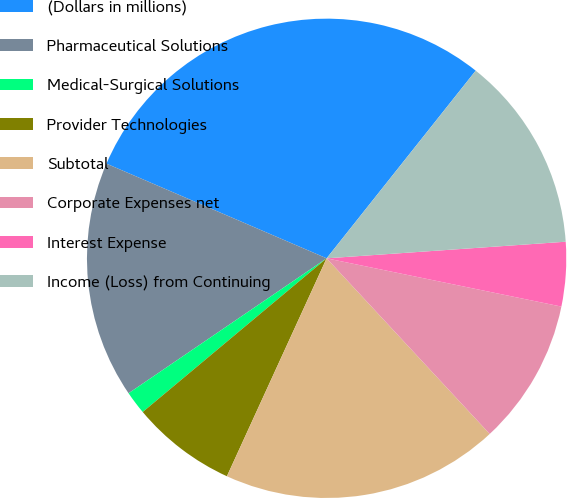Convert chart to OTSL. <chart><loc_0><loc_0><loc_500><loc_500><pie_chart><fcel>(Dollars in millions)<fcel>Pharmaceutical Solutions<fcel>Medical-Surgical Solutions<fcel>Provider Technologies<fcel>Subtotal<fcel>Corporate Expenses net<fcel>Interest Expense<fcel>Income (Loss) from Continuing<nl><fcel>29.22%<fcel>15.98%<fcel>1.56%<fcel>7.09%<fcel>18.74%<fcel>9.86%<fcel>4.33%<fcel>13.21%<nl></chart> 